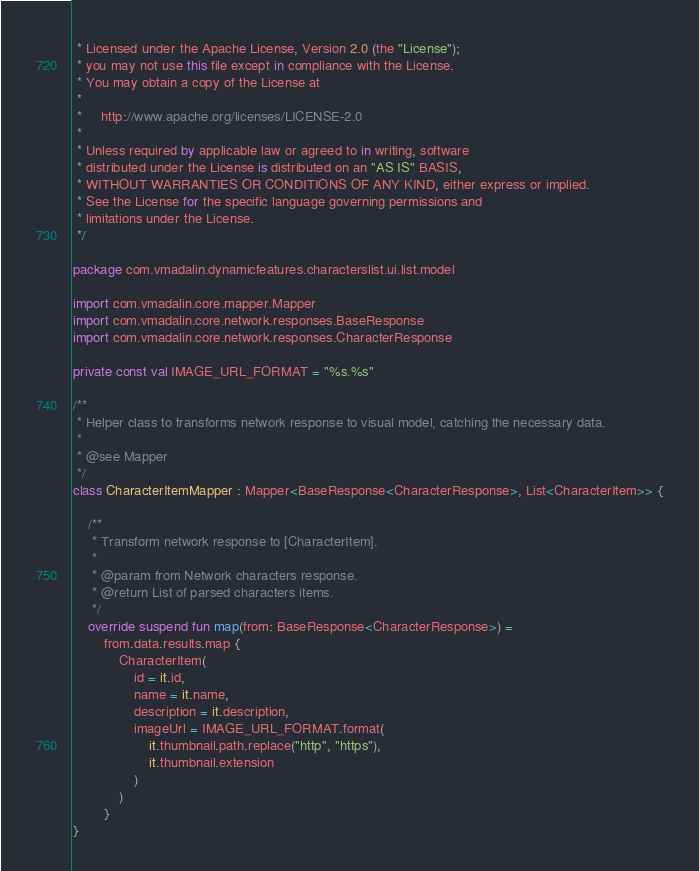Convert code to text. <code><loc_0><loc_0><loc_500><loc_500><_Kotlin_> * Licensed under the Apache License, Version 2.0 (the "License");
 * you may not use this file except in compliance with the License.
 * You may obtain a copy of the License at
 *
 *     http://www.apache.org/licenses/LICENSE-2.0
 *
 * Unless required by applicable law or agreed to in writing, software
 * distributed under the License is distributed on an "AS IS" BASIS,
 * WITHOUT WARRANTIES OR CONDITIONS OF ANY KIND, either express or implied.
 * See the License for the specific language governing permissions and
 * limitations under the License.
 */

package com.vmadalin.dynamicfeatures.characterslist.ui.list.model

import com.vmadalin.core.mapper.Mapper
import com.vmadalin.core.network.responses.BaseResponse
import com.vmadalin.core.network.responses.CharacterResponse

private const val IMAGE_URL_FORMAT = "%s.%s"

/**
 * Helper class to transforms network response to visual model, catching the necessary data.
 *
 * @see Mapper
 */
class CharacterItemMapper : Mapper<BaseResponse<CharacterResponse>, List<CharacterItem>> {

    /**
     * Transform network response to [CharacterItem].
     *
     * @param from Network characters response.
     * @return List of parsed characters items.
     */
    override suspend fun map(from: BaseResponse<CharacterResponse>) =
        from.data.results.map {
            CharacterItem(
                id = it.id,
                name = it.name,
                description = it.description,
                imageUrl = IMAGE_URL_FORMAT.format(
                    it.thumbnail.path.replace("http", "https"),
                    it.thumbnail.extension
                )
            )
        }
}
</code> 